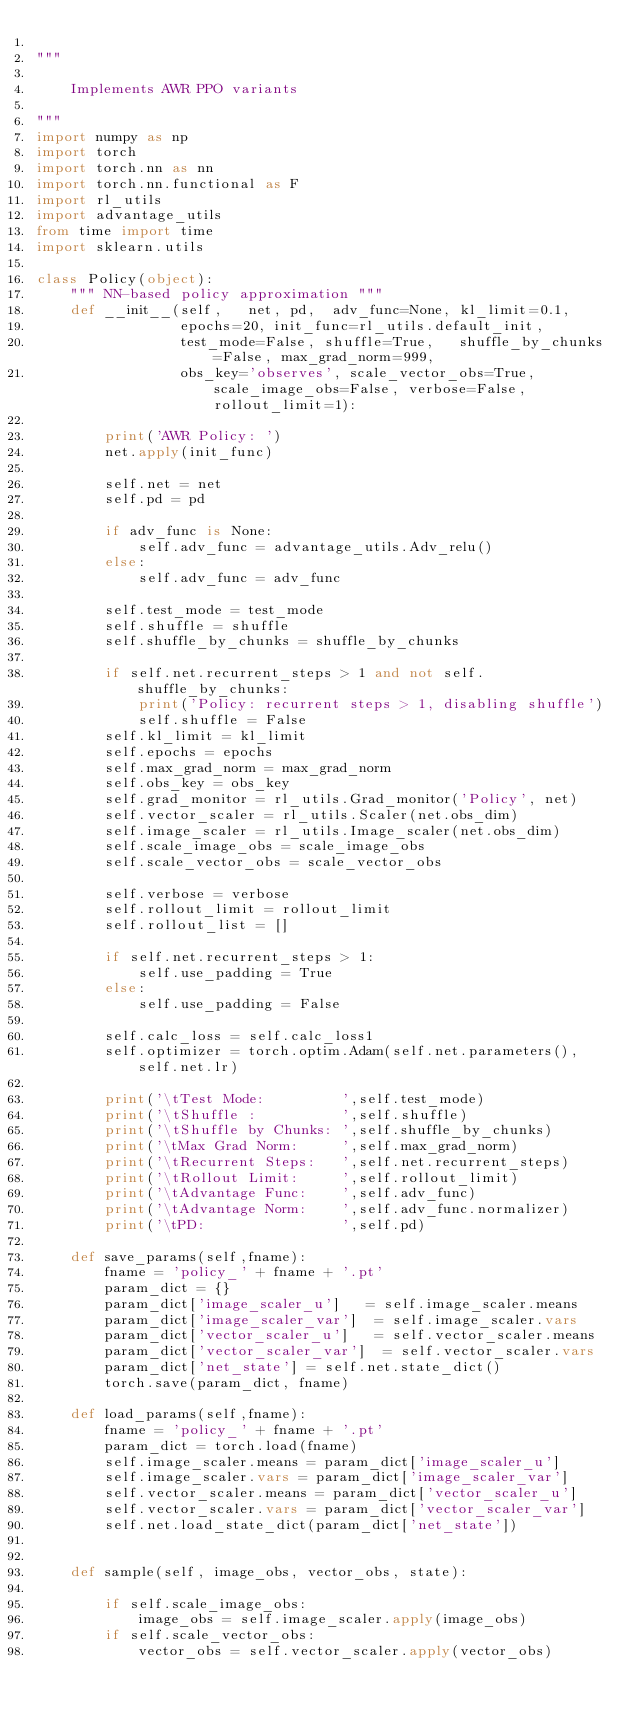<code> <loc_0><loc_0><loc_500><loc_500><_Python_>
"""

    Implements AWR PPO variants
 
"""
import numpy as np
import torch
import torch.nn as nn
import torch.nn.functional as F
import rl_utils
import advantage_utils
from time import time
import sklearn.utils
 
class Policy(object):
    """ NN-based policy approximation """
    def __init__(self,   net, pd,  adv_func=None, kl_limit=0.1, 
                 epochs=20, init_func=rl_utils.default_init, 
                 test_mode=False, shuffle=True,   shuffle_by_chunks=False, max_grad_norm=999, 
                 obs_key='observes', scale_vector_obs=True, scale_image_obs=False, verbose=False, rollout_limit=1):

        print('AWR Policy: ')
        net.apply(init_func)

        self.net = net
        self.pd = pd

        if adv_func is None:
            self.adv_func = advantage_utils.Adv_relu()
        else:
            self.adv_func = adv_func

        self.test_mode = test_mode
        self.shuffle = shuffle
        self.shuffle_by_chunks = shuffle_by_chunks

        if self.net.recurrent_steps > 1 and not self.shuffle_by_chunks:
            print('Policy: recurrent steps > 1, disabling shuffle')
            self.shuffle = False
        self.kl_limit = kl_limit
        self.epochs = epochs 
        self.max_grad_norm = max_grad_norm
        self.obs_key = obs_key
        self.grad_monitor = rl_utils.Grad_monitor('Policy', net)
        self.vector_scaler = rl_utils.Scaler(net.obs_dim)
        self.image_scaler = rl_utils.Image_scaler(net.obs_dim)
        self.scale_image_obs = scale_image_obs
        self.scale_vector_obs = scale_vector_obs

        self.verbose = verbose 
        self.rollout_limit = rollout_limit
        self.rollout_list = []

        if self.net.recurrent_steps > 1:
            self.use_padding = True
        else:
            self.use_padding = False

        self.calc_loss = self.calc_loss1
        self.optimizer = torch.optim.Adam(self.net.parameters(), self.net.lr)

        print('\tTest Mode:         ',self.test_mode)
        print('\tShuffle :          ',self.shuffle)
        print('\tShuffle by Chunks: ',self.shuffle_by_chunks)
        print('\tMax Grad Norm:     ',self.max_grad_norm)
        print('\tRecurrent Steps:   ',self.net.recurrent_steps)
        print('\tRollout Limit:     ',self.rollout_limit)
        print('\tAdvantage Func:    ',self.adv_func)
        print('\tAdvantage Norm:    ',self.adv_func.normalizer)
        print('\tPD:                ',self.pd)

    def save_params(self,fname):
        fname = 'policy_' + fname + '.pt'
        param_dict = {}
        param_dict['image_scaler_u']   = self.image_scaler.means
        param_dict['image_scaler_var']  = self.image_scaler.vars
        param_dict['vector_scaler_u']   = self.vector_scaler.means
        param_dict['vector_scaler_var']  = self.vector_scaler.vars
        param_dict['net_state'] = self.net.state_dict()
        torch.save(param_dict, fname)

    def load_params(self,fname):
        fname = 'policy_' + fname + '.pt'
        param_dict = torch.load(fname)
        self.image_scaler.means = param_dict['image_scaler_u']
        self.image_scaler.vars = param_dict['image_scaler_var']
        self.vector_scaler.means = param_dict['vector_scaler_u']
        self.vector_scaler.vars = param_dict['vector_scaler_var']
        self.net.load_state_dict(param_dict['net_state'])


    def sample(self, image_obs, vector_obs, state):

        if self.scale_image_obs:
            image_obs = self.image_scaler.apply(image_obs)
        if self.scale_vector_obs:
            vector_obs = self.vector_scaler.apply(vector_obs)</code> 